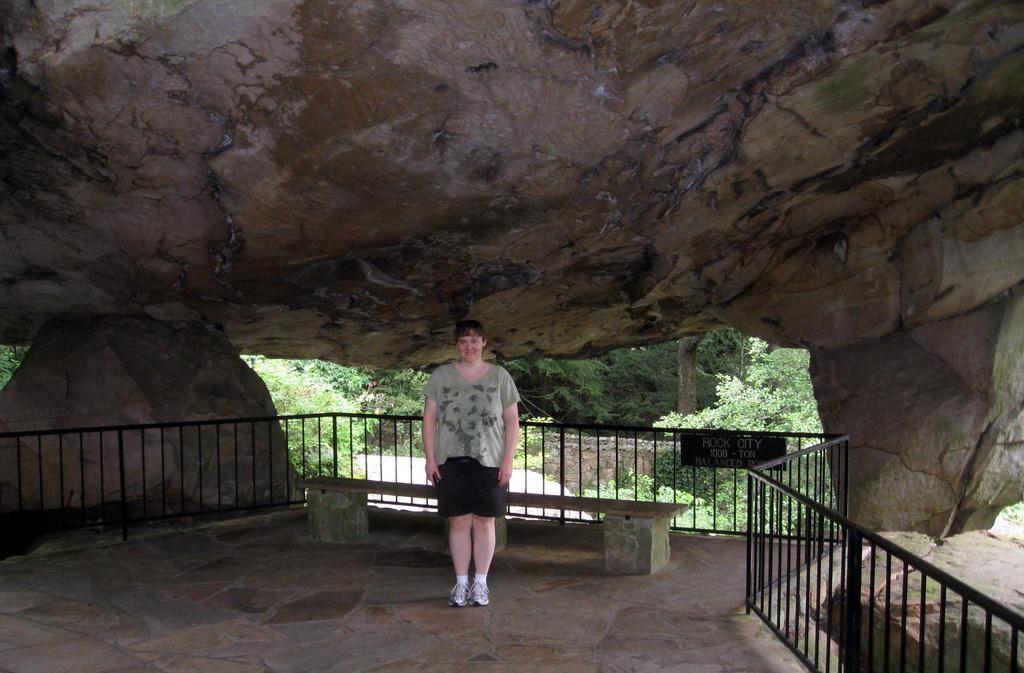Could you give a brief overview of what you see in this image? This picture shows a rock and we see a bench and a metal fence and we see a woman standing and few trees. 